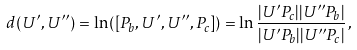Convert formula to latex. <formula><loc_0><loc_0><loc_500><loc_500>d ( U ^ { \prime } , U ^ { \prime \prime } ) = \ln ( [ P _ { b } , U ^ { \prime } , U ^ { \prime \prime } , P _ { c } ] ) = \ln \frac { | U ^ { \prime } P _ { c } | | U ^ { \prime \prime } P _ { b } | } { | U ^ { \prime } P _ { b } | | U ^ { \prime \prime } P _ { c } | } \, ,</formula> 